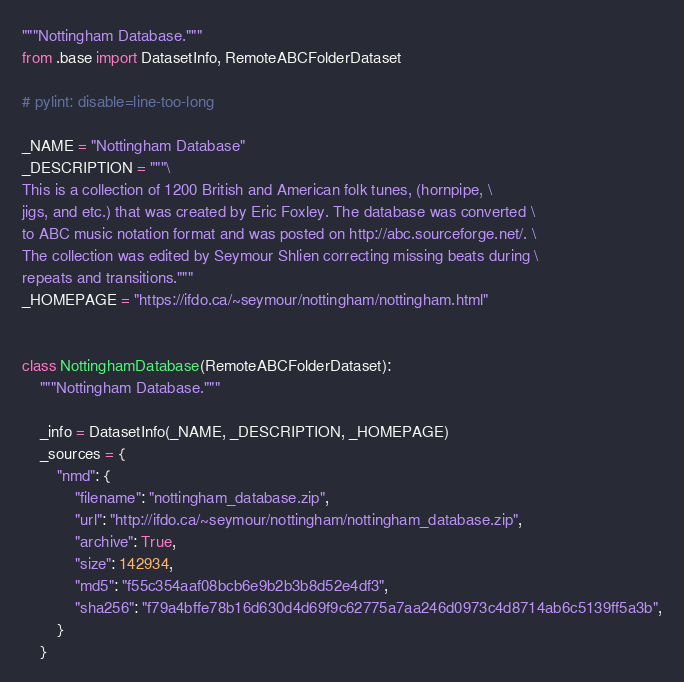<code> <loc_0><loc_0><loc_500><loc_500><_Python_>"""Nottingham Database."""
from .base import DatasetInfo, RemoteABCFolderDataset

# pylint: disable=line-too-long

_NAME = "Nottingham Database"
_DESCRIPTION = """\
This is a collection of 1200 British and American folk tunes, (hornpipe, \
jigs, and etc.) that was created by Eric Foxley. The database was converted \
to ABC music notation format and was posted on http://abc.sourceforge.net/. \
The collection was edited by Seymour Shlien correcting missing beats during \
repeats and transitions."""
_HOMEPAGE = "https://ifdo.ca/~seymour/nottingham/nottingham.html"


class NottinghamDatabase(RemoteABCFolderDataset):
    """Nottingham Database."""

    _info = DatasetInfo(_NAME, _DESCRIPTION, _HOMEPAGE)
    _sources = {
        "nmd": {
            "filename": "nottingham_database.zip",
            "url": "http://ifdo.ca/~seymour/nottingham/nottingham_database.zip",
            "archive": True,
            "size": 142934,
            "md5": "f55c354aaf08bcb6e9b2b3b8d52e4df3",
            "sha256": "f79a4bffe78b16d630d4d69f9c62775a7aa246d0973c4d8714ab6c5139ff5a3b",
        }
    }
</code> 